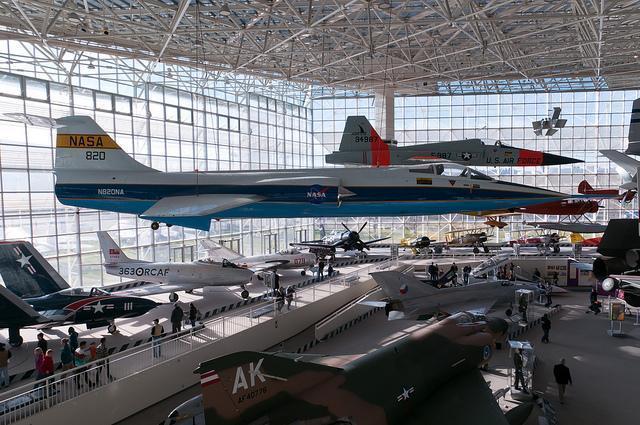What type of transportation is shown?
Choose the correct response and explain in the format: 'Answer: answer
Rationale: rationale.'
Options: Air, water, land, rail. Answer: air.
Rationale: The planes fly in the air. 